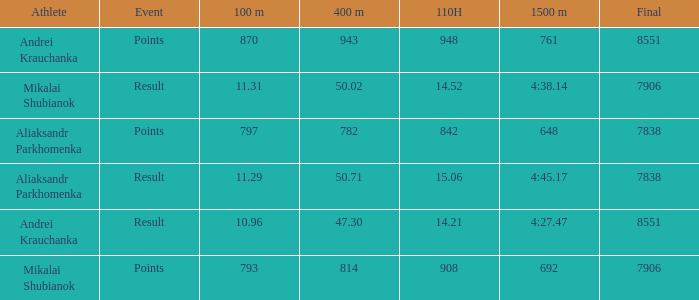What was the 110H that the 1500m was 692 and the final was more than 7906? 0.0. 